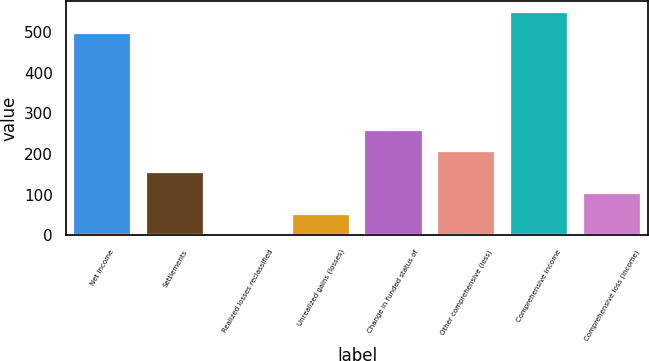<chart> <loc_0><loc_0><loc_500><loc_500><bar_chart><fcel>Net income<fcel>Settlements<fcel>Realized losses reclassified<fcel>Unrealized gains (losses)<fcel>Change in funded status of<fcel>Other comprehensive (loss)<fcel>Comprehensive income<fcel>Comprehensive loss (income)<nl><fcel>496.5<fcel>156.42<fcel>1.2<fcel>52.94<fcel>259.9<fcel>208.16<fcel>548.24<fcel>104.68<nl></chart> 